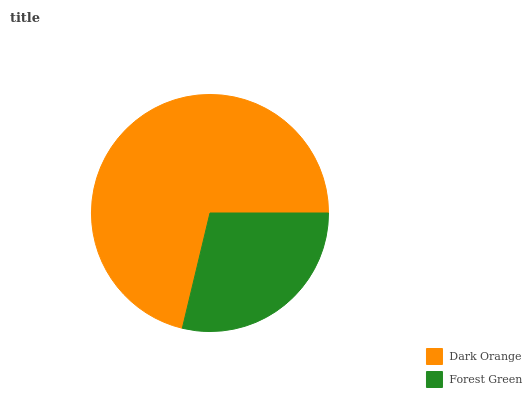Is Forest Green the minimum?
Answer yes or no. Yes. Is Dark Orange the maximum?
Answer yes or no. Yes. Is Forest Green the maximum?
Answer yes or no. No. Is Dark Orange greater than Forest Green?
Answer yes or no. Yes. Is Forest Green less than Dark Orange?
Answer yes or no. Yes. Is Forest Green greater than Dark Orange?
Answer yes or no. No. Is Dark Orange less than Forest Green?
Answer yes or no. No. Is Dark Orange the high median?
Answer yes or no. Yes. Is Forest Green the low median?
Answer yes or no. Yes. Is Forest Green the high median?
Answer yes or no. No. Is Dark Orange the low median?
Answer yes or no. No. 